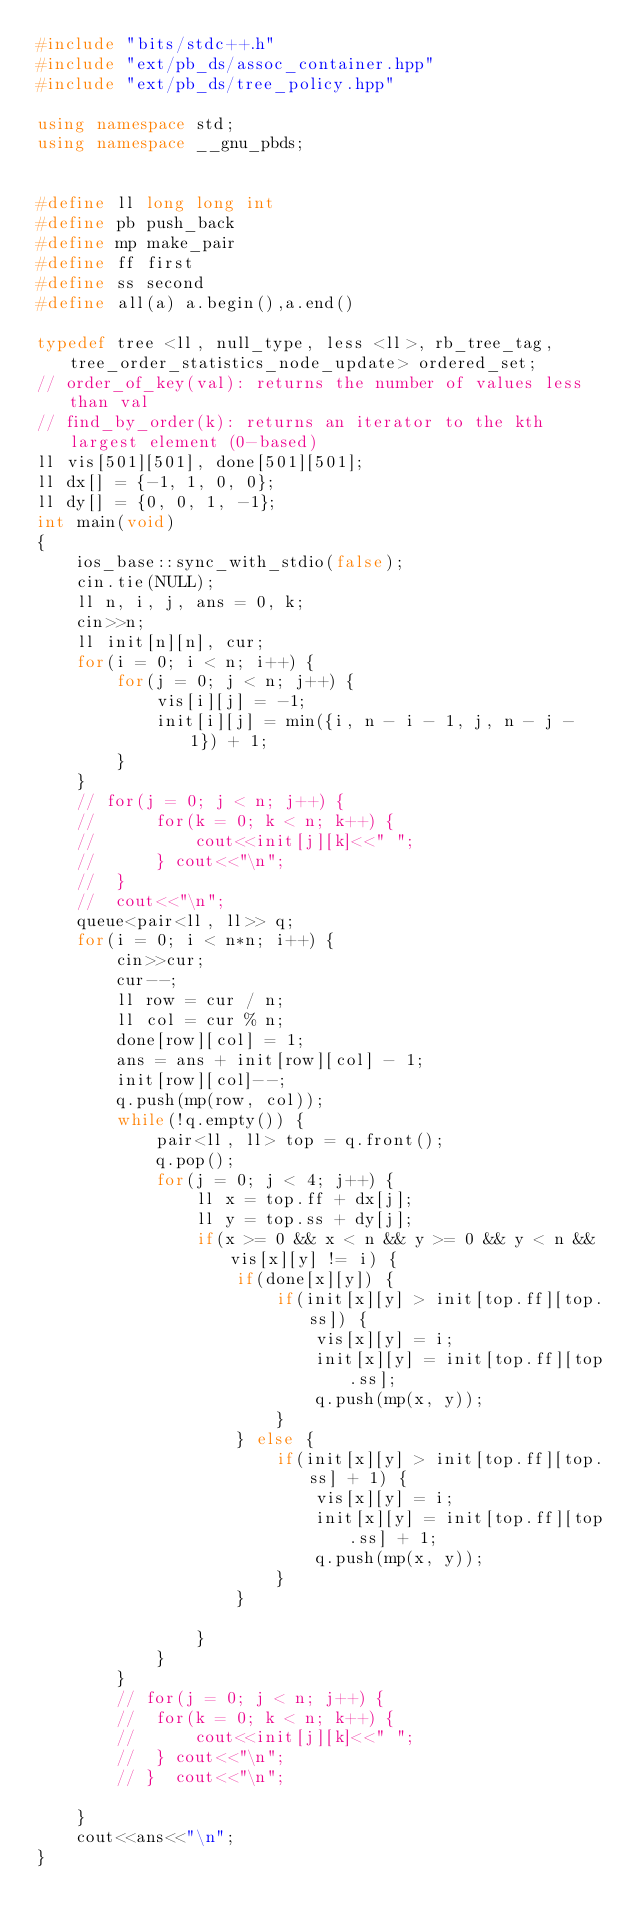Convert code to text. <code><loc_0><loc_0><loc_500><loc_500><_C++_>#include "bits/stdc++.h"
#include "ext/pb_ds/assoc_container.hpp"
#include "ext/pb_ds/tree_policy.hpp"

using namespace std;
using namespace __gnu_pbds;


#define ll long long int
#define pb push_back
#define mp make_pair
#define ff first
#define ss second
#define all(a) a.begin(),a.end()

typedef tree <ll, null_type, less <ll>, rb_tree_tag, tree_order_statistics_node_update> ordered_set;
// order_of_key(val): returns the number of values less than val
// find_by_order(k): returns an iterator to the kth largest element (0-based)
ll vis[501][501], done[501][501];
ll dx[] = {-1, 1, 0, 0};
ll dy[] = {0, 0, 1, -1};
int main(void)
{
	ios_base::sync_with_stdio(false);
    cin.tie(NULL);
    ll n, i, j, ans = 0, k;
    cin>>n;
    ll init[n][n], cur;
    for(i = 0; i < n; i++) {
    	for(j = 0; j < n; j++) {
    		vis[i][j] = -1;
    		init[i][j] = min({i, n - i - 1, j, n - j - 1}) + 1;
    	}
    }
    // for(j = 0; j < n; j++) {
    // 		for(k = 0; k < n; k++) {
    // 			cout<<init[j][k]<<" ";
    // 		} cout<<"\n";
    // 	} 
    // 	cout<<"\n";
    queue<pair<ll, ll>> q;
    for(i = 0; i < n*n; i++) {
    	cin>>cur;
    	cur--;
    	ll row = cur / n;
    	ll col = cur % n;
    	done[row][col] = 1;
    	ans = ans + init[row][col] - 1;
    	init[row][col]--;
    	q.push(mp(row, col));
    	while(!q.empty()) {
    		pair<ll, ll> top = q.front();
    		q.pop();
    		for(j = 0; j < 4; j++) {
    			ll x = top.ff + dx[j];
    			ll y = top.ss + dy[j];
    			if(x >= 0 && x < n && y >= 0 && y < n && vis[x][y] != i) {
    				if(done[x][y]) {
    					if(init[x][y] > init[top.ff][top.ss]) {
    						vis[x][y] = i;
    						init[x][y] = init[top.ff][top.ss];
    						q.push(mp(x, y));
    					}
    				} else {
	    				if(init[x][y] > init[top.ff][top.ss] + 1) {
	    					vis[x][y] = i;
	    					init[x][y] = init[top.ff][top.ss] + 1;
	    					q.push(mp(x, y));
	    				}
	    			}

    			}
    		}
    	}
    	// for(j = 0; j < n; j++) {
    	// 	for(k = 0; k < n; k++) {
    	// 		cout<<init[j][k]<<" ";
    	// 	} cout<<"\n";
    	// }  cout<<"\n";
    	
    }
    cout<<ans<<"\n";
}	</code> 